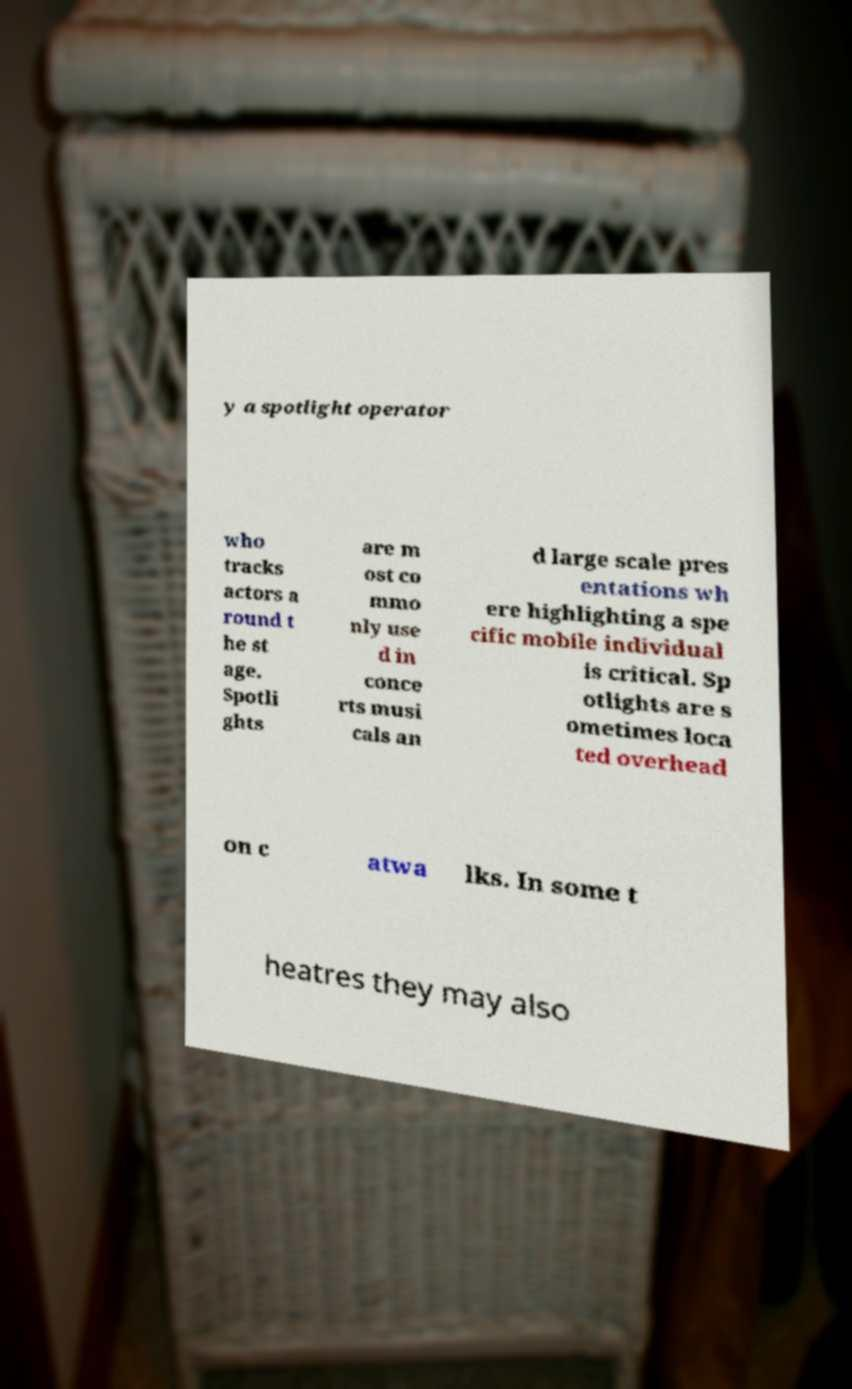Can you accurately transcribe the text from the provided image for me? y a spotlight operator who tracks actors a round t he st age. Spotli ghts are m ost co mmo nly use d in conce rts musi cals an d large scale pres entations wh ere highlighting a spe cific mobile individual is critical. Sp otlights are s ometimes loca ted overhead on c atwa lks. In some t heatres they may also 